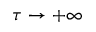Convert formula to latex. <formula><loc_0><loc_0><loc_500><loc_500>\tau \rightarrow + \infty</formula> 